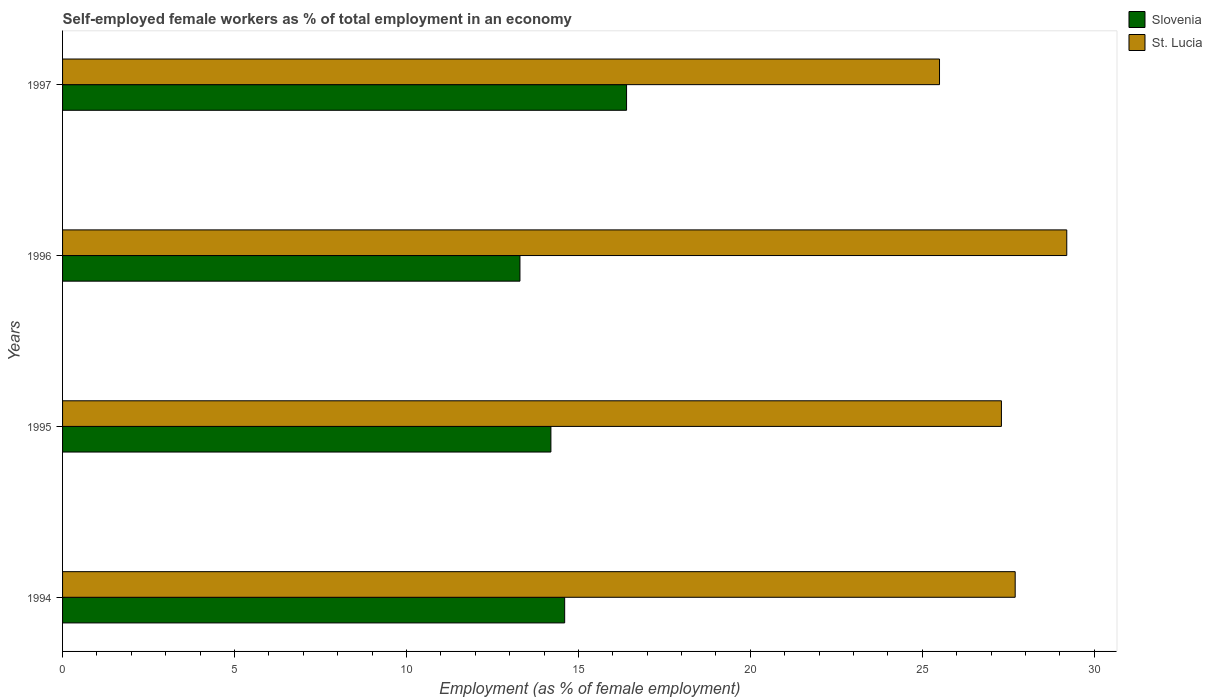How many bars are there on the 3rd tick from the bottom?
Provide a short and direct response. 2. What is the label of the 3rd group of bars from the top?
Your answer should be compact. 1995. What is the percentage of self-employed female workers in Slovenia in 1996?
Your answer should be compact. 13.3. Across all years, what is the maximum percentage of self-employed female workers in Slovenia?
Make the answer very short. 16.4. Across all years, what is the minimum percentage of self-employed female workers in Slovenia?
Offer a terse response. 13.3. In which year was the percentage of self-employed female workers in Slovenia maximum?
Offer a terse response. 1997. What is the total percentage of self-employed female workers in St. Lucia in the graph?
Provide a succinct answer. 109.7. What is the difference between the percentage of self-employed female workers in Slovenia in 1994 and that in 1997?
Keep it short and to the point. -1.8. What is the difference between the percentage of self-employed female workers in Slovenia in 1994 and the percentage of self-employed female workers in St. Lucia in 1997?
Keep it short and to the point. -10.9. What is the average percentage of self-employed female workers in Slovenia per year?
Give a very brief answer. 14.62. In the year 1994, what is the difference between the percentage of self-employed female workers in St. Lucia and percentage of self-employed female workers in Slovenia?
Ensure brevity in your answer.  13.1. In how many years, is the percentage of self-employed female workers in Slovenia greater than 11 %?
Your answer should be very brief. 4. What is the ratio of the percentage of self-employed female workers in St. Lucia in 1994 to that in 1997?
Keep it short and to the point. 1.09. Is the percentage of self-employed female workers in Slovenia in 1994 less than that in 1996?
Offer a terse response. No. Is the difference between the percentage of self-employed female workers in St. Lucia in 1996 and 1997 greater than the difference between the percentage of self-employed female workers in Slovenia in 1996 and 1997?
Provide a short and direct response. Yes. What is the difference between the highest and the second highest percentage of self-employed female workers in St. Lucia?
Keep it short and to the point. 1.5. What is the difference between the highest and the lowest percentage of self-employed female workers in Slovenia?
Make the answer very short. 3.1. In how many years, is the percentage of self-employed female workers in St. Lucia greater than the average percentage of self-employed female workers in St. Lucia taken over all years?
Your answer should be very brief. 2. What does the 2nd bar from the top in 1996 represents?
Your answer should be compact. Slovenia. What does the 1st bar from the bottom in 1996 represents?
Your answer should be very brief. Slovenia. How many bars are there?
Your response must be concise. 8. Are all the bars in the graph horizontal?
Ensure brevity in your answer.  Yes. What is the difference between two consecutive major ticks on the X-axis?
Offer a very short reply. 5. Does the graph contain grids?
Offer a very short reply. No. Where does the legend appear in the graph?
Make the answer very short. Top right. What is the title of the graph?
Give a very brief answer. Self-employed female workers as % of total employment in an economy. What is the label or title of the X-axis?
Your answer should be compact. Employment (as % of female employment). What is the label or title of the Y-axis?
Offer a very short reply. Years. What is the Employment (as % of female employment) in Slovenia in 1994?
Make the answer very short. 14.6. What is the Employment (as % of female employment) in St. Lucia in 1994?
Your answer should be compact. 27.7. What is the Employment (as % of female employment) in Slovenia in 1995?
Offer a terse response. 14.2. What is the Employment (as % of female employment) of St. Lucia in 1995?
Ensure brevity in your answer.  27.3. What is the Employment (as % of female employment) in Slovenia in 1996?
Your response must be concise. 13.3. What is the Employment (as % of female employment) in St. Lucia in 1996?
Ensure brevity in your answer.  29.2. What is the Employment (as % of female employment) in Slovenia in 1997?
Keep it short and to the point. 16.4. Across all years, what is the maximum Employment (as % of female employment) in Slovenia?
Ensure brevity in your answer.  16.4. Across all years, what is the maximum Employment (as % of female employment) of St. Lucia?
Keep it short and to the point. 29.2. Across all years, what is the minimum Employment (as % of female employment) in Slovenia?
Your response must be concise. 13.3. Across all years, what is the minimum Employment (as % of female employment) in St. Lucia?
Provide a succinct answer. 25.5. What is the total Employment (as % of female employment) in Slovenia in the graph?
Offer a very short reply. 58.5. What is the total Employment (as % of female employment) in St. Lucia in the graph?
Your answer should be compact. 109.7. What is the difference between the Employment (as % of female employment) of St. Lucia in 1994 and that in 1995?
Keep it short and to the point. 0.4. What is the difference between the Employment (as % of female employment) of Slovenia in 1994 and that in 1997?
Your answer should be very brief. -1.8. What is the difference between the Employment (as % of female employment) in Slovenia in 1995 and that in 1996?
Offer a very short reply. 0.9. What is the difference between the Employment (as % of female employment) in St. Lucia in 1995 and that in 1996?
Give a very brief answer. -1.9. What is the difference between the Employment (as % of female employment) of Slovenia in 1995 and that in 1997?
Provide a short and direct response. -2.2. What is the difference between the Employment (as % of female employment) in St. Lucia in 1996 and that in 1997?
Keep it short and to the point. 3.7. What is the difference between the Employment (as % of female employment) of Slovenia in 1994 and the Employment (as % of female employment) of St. Lucia in 1996?
Ensure brevity in your answer.  -14.6. What is the difference between the Employment (as % of female employment) of Slovenia in 1995 and the Employment (as % of female employment) of St. Lucia in 1996?
Offer a terse response. -15. What is the difference between the Employment (as % of female employment) in Slovenia in 1996 and the Employment (as % of female employment) in St. Lucia in 1997?
Your answer should be very brief. -12.2. What is the average Employment (as % of female employment) in Slovenia per year?
Offer a terse response. 14.62. What is the average Employment (as % of female employment) in St. Lucia per year?
Make the answer very short. 27.43. In the year 1996, what is the difference between the Employment (as % of female employment) of Slovenia and Employment (as % of female employment) of St. Lucia?
Provide a succinct answer. -15.9. What is the ratio of the Employment (as % of female employment) of Slovenia in 1994 to that in 1995?
Ensure brevity in your answer.  1.03. What is the ratio of the Employment (as % of female employment) of St. Lucia in 1994 to that in 1995?
Give a very brief answer. 1.01. What is the ratio of the Employment (as % of female employment) in Slovenia in 1994 to that in 1996?
Your answer should be compact. 1.1. What is the ratio of the Employment (as % of female employment) in St. Lucia in 1994 to that in 1996?
Ensure brevity in your answer.  0.95. What is the ratio of the Employment (as % of female employment) in Slovenia in 1994 to that in 1997?
Make the answer very short. 0.89. What is the ratio of the Employment (as % of female employment) of St. Lucia in 1994 to that in 1997?
Keep it short and to the point. 1.09. What is the ratio of the Employment (as % of female employment) in Slovenia in 1995 to that in 1996?
Offer a very short reply. 1.07. What is the ratio of the Employment (as % of female employment) in St. Lucia in 1995 to that in 1996?
Provide a succinct answer. 0.93. What is the ratio of the Employment (as % of female employment) of Slovenia in 1995 to that in 1997?
Your answer should be very brief. 0.87. What is the ratio of the Employment (as % of female employment) in St. Lucia in 1995 to that in 1997?
Provide a short and direct response. 1.07. What is the ratio of the Employment (as % of female employment) in Slovenia in 1996 to that in 1997?
Give a very brief answer. 0.81. What is the ratio of the Employment (as % of female employment) in St. Lucia in 1996 to that in 1997?
Give a very brief answer. 1.15. What is the difference between the highest and the second highest Employment (as % of female employment) of Slovenia?
Offer a terse response. 1.8. 